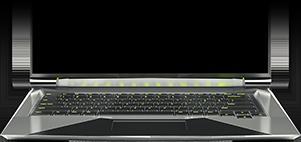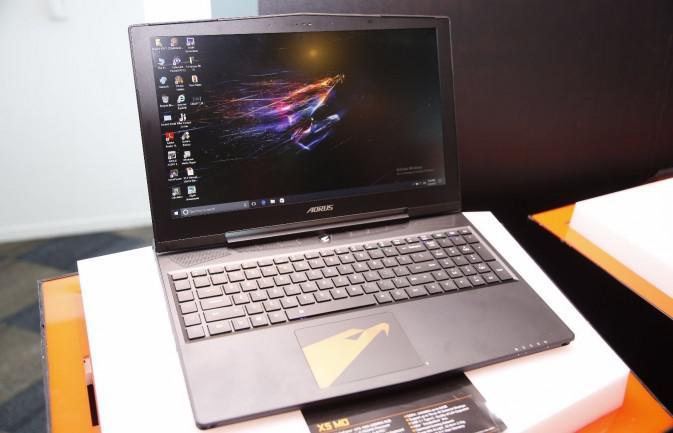The first image is the image on the left, the second image is the image on the right. Evaluate the accuracy of this statement regarding the images: "Wires are coming out the right side of the computer in at least one of the images.". Is it true? Answer yes or no. No. 